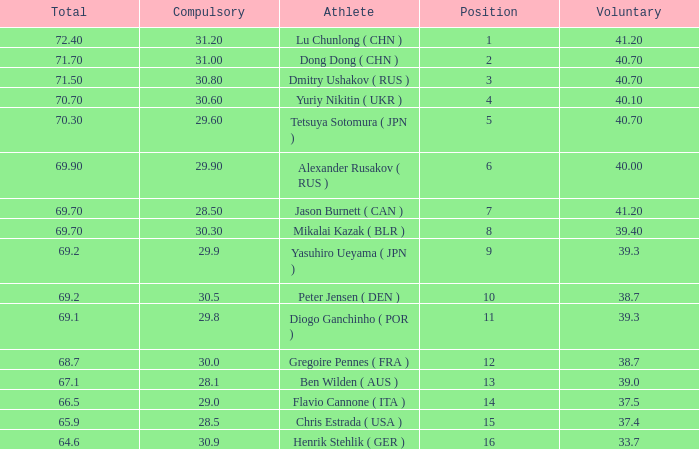What's the total compulsory when the total is more than 69.2 and the voluntary is 38.7? 0.0. 